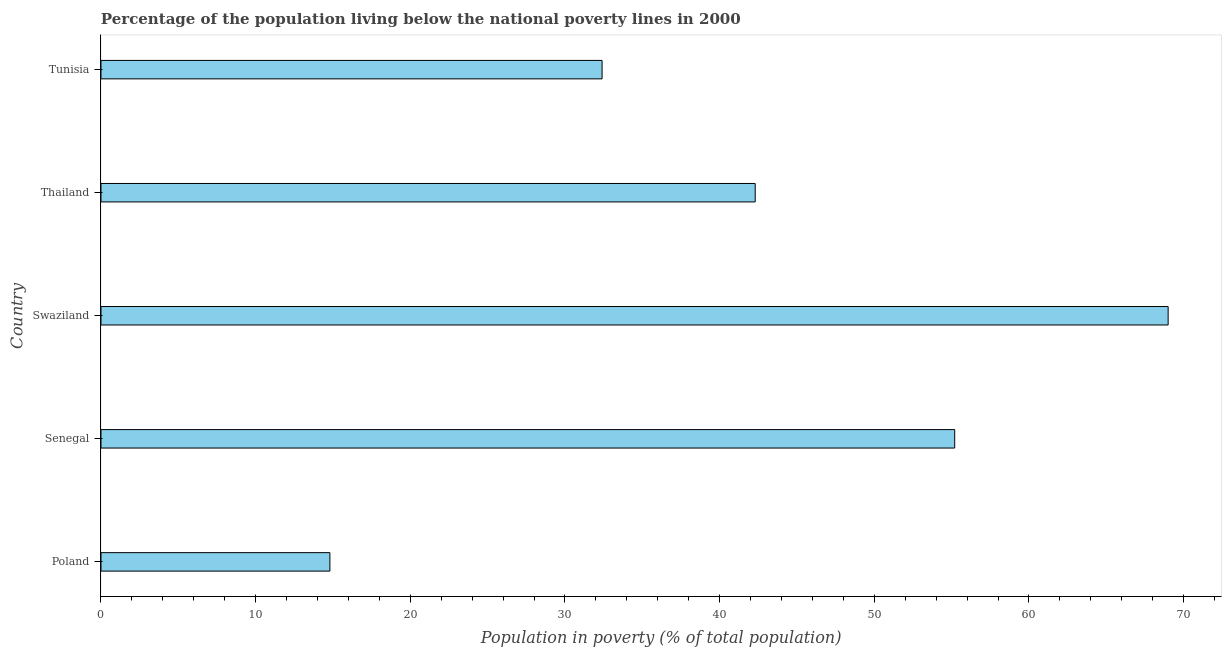Does the graph contain any zero values?
Give a very brief answer. No. What is the title of the graph?
Make the answer very short. Percentage of the population living below the national poverty lines in 2000. What is the label or title of the X-axis?
Offer a very short reply. Population in poverty (% of total population). Across all countries, what is the maximum percentage of population living below poverty line?
Keep it short and to the point. 69. In which country was the percentage of population living below poverty line maximum?
Give a very brief answer. Swaziland. In which country was the percentage of population living below poverty line minimum?
Your answer should be very brief. Poland. What is the sum of the percentage of population living below poverty line?
Offer a very short reply. 213.7. What is the difference between the percentage of population living below poverty line in Swaziland and Thailand?
Offer a terse response. 26.7. What is the average percentage of population living below poverty line per country?
Provide a short and direct response. 42.74. What is the median percentage of population living below poverty line?
Your answer should be very brief. 42.3. In how many countries, is the percentage of population living below poverty line greater than 64 %?
Your answer should be compact. 1. What is the ratio of the percentage of population living below poverty line in Poland to that in Senegal?
Your answer should be compact. 0.27. Is the difference between the percentage of population living below poverty line in Thailand and Tunisia greater than the difference between any two countries?
Your answer should be compact. No. What is the difference between the highest and the second highest percentage of population living below poverty line?
Ensure brevity in your answer.  13.8. What is the difference between the highest and the lowest percentage of population living below poverty line?
Provide a succinct answer. 54.2. How many bars are there?
Give a very brief answer. 5. What is the difference between two consecutive major ticks on the X-axis?
Offer a very short reply. 10. Are the values on the major ticks of X-axis written in scientific E-notation?
Ensure brevity in your answer.  No. What is the Population in poverty (% of total population) in Senegal?
Provide a succinct answer. 55.2. What is the Population in poverty (% of total population) in Swaziland?
Provide a succinct answer. 69. What is the Population in poverty (% of total population) of Thailand?
Your answer should be compact. 42.3. What is the Population in poverty (% of total population) of Tunisia?
Make the answer very short. 32.4. What is the difference between the Population in poverty (% of total population) in Poland and Senegal?
Offer a terse response. -40.4. What is the difference between the Population in poverty (% of total population) in Poland and Swaziland?
Give a very brief answer. -54.2. What is the difference between the Population in poverty (% of total population) in Poland and Thailand?
Provide a short and direct response. -27.5. What is the difference between the Population in poverty (% of total population) in Poland and Tunisia?
Offer a very short reply. -17.6. What is the difference between the Population in poverty (% of total population) in Senegal and Tunisia?
Offer a terse response. 22.8. What is the difference between the Population in poverty (% of total population) in Swaziland and Thailand?
Provide a short and direct response. 26.7. What is the difference between the Population in poverty (% of total population) in Swaziland and Tunisia?
Provide a succinct answer. 36.6. What is the ratio of the Population in poverty (% of total population) in Poland to that in Senegal?
Your answer should be compact. 0.27. What is the ratio of the Population in poverty (% of total population) in Poland to that in Swaziland?
Your response must be concise. 0.21. What is the ratio of the Population in poverty (% of total population) in Poland to that in Thailand?
Make the answer very short. 0.35. What is the ratio of the Population in poverty (% of total population) in Poland to that in Tunisia?
Offer a very short reply. 0.46. What is the ratio of the Population in poverty (% of total population) in Senegal to that in Swaziland?
Your answer should be very brief. 0.8. What is the ratio of the Population in poverty (% of total population) in Senegal to that in Thailand?
Ensure brevity in your answer.  1.3. What is the ratio of the Population in poverty (% of total population) in Senegal to that in Tunisia?
Your response must be concise. 1.7. What is the ratio of the Population in poverty (% of total population) in Swaziland to that in Thailand?
Keep it short and to the point. 1.63. What is the ratio of the Population in poverty (% of total population) in Swaziland to that in Tunisia?
Ensure brevity in your answer.  2.13. What is the ratio of the Population in poverty (% of total population) in Thailand to that in Tunisia?
Your response must be concise. 1.31. 